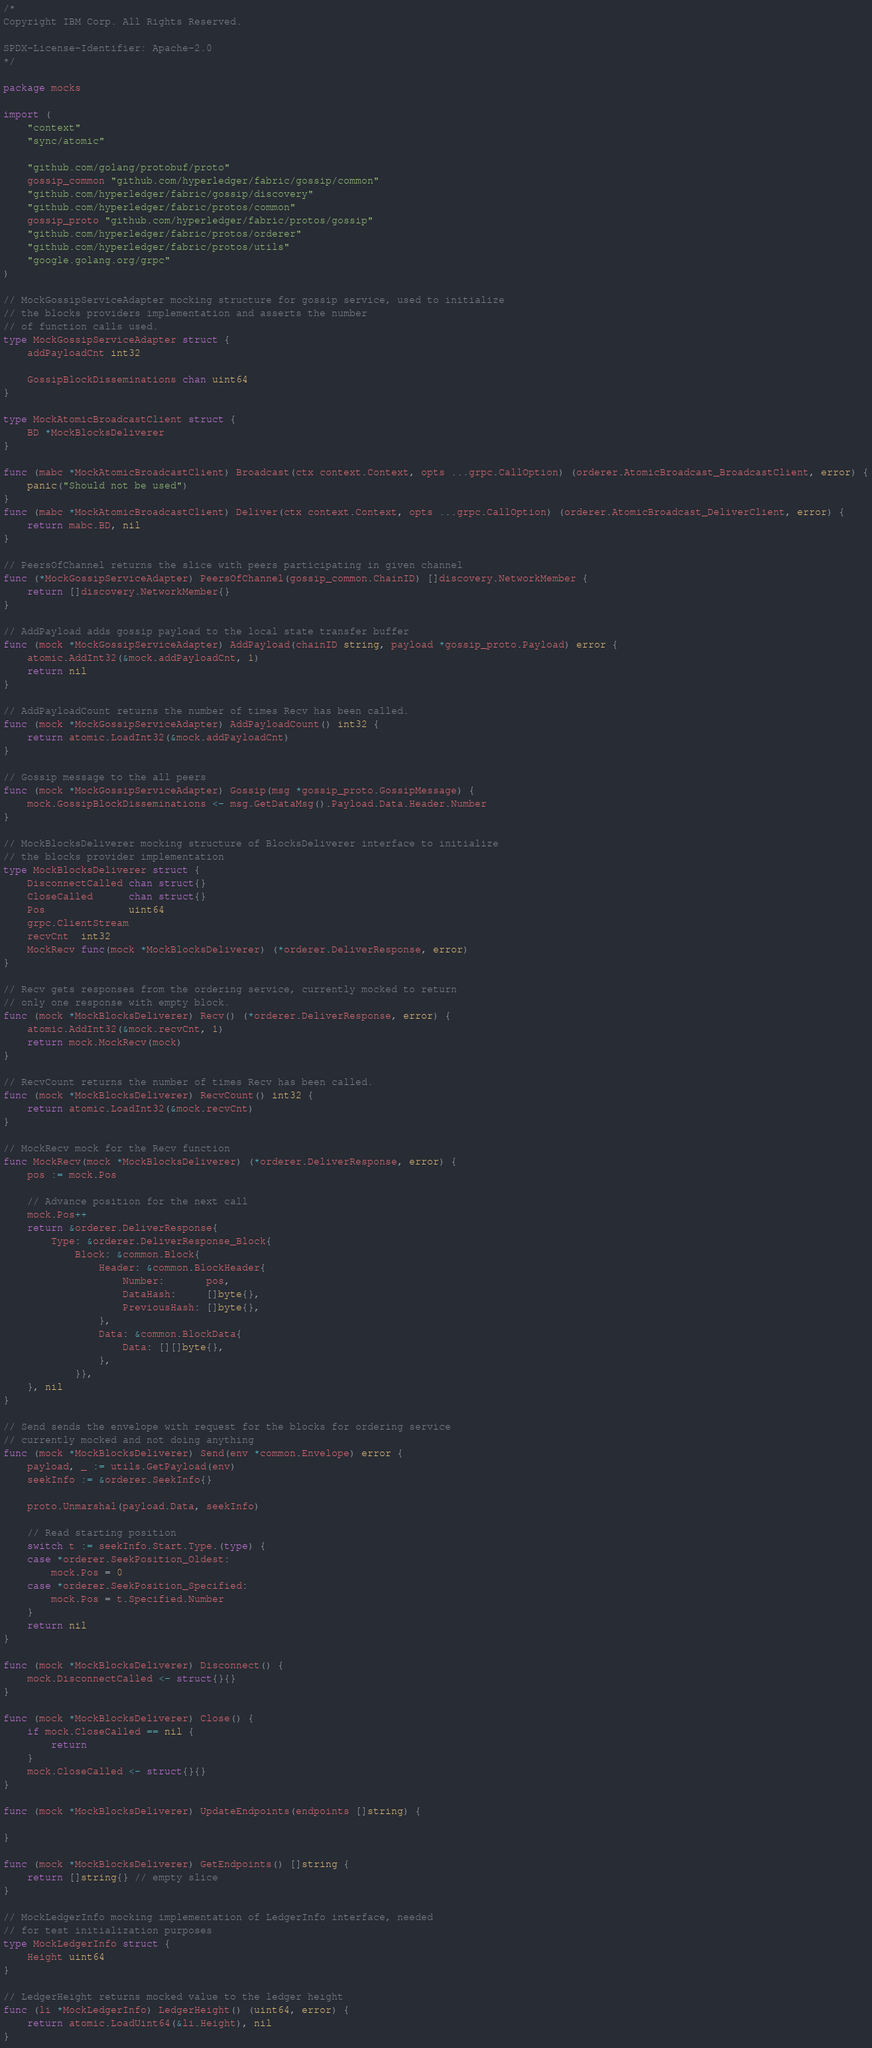Convert code to text. <code><loc_0><loc_0><loc_500><loc_500><_Go_>/*
Copyright IBM Corp. All Rights Reserved.

SPDX-License-Identifier: Apache-2.0
*/

package mocks

import (
	"context"
	"sync/atomic"

	"github.com/golang/protobuf/proto"
	gossip_common "github.com/hyperledger/fabric/gossip/common"
	"github.com/hyperledger/fabric/gossip/discovery"
	"github.com/hyperledger/fabric/protos/common"
	gossip_proto "github.com/hyperledger/fabric/protos/gossip"
	"github.com/hyperledger/fabric/protos/orderer"
	"github.com/hyperledger/fabric/protos/utils"
	"google.golang.org/grpc"
)

// MockGossipServiceAdapter mocking structure for gossip service, used to initialize
// the blocks providers implementation and asserts the number
// of function calls used.
type MockGossipServiceAdapter struct {
	addPayloadCnt int32

	GossipBlockDisseminations chan uint64
}

type MockAtomicBroadcastClient struct {
	BD *MockBlocksDeliverer
}

func (mabc *MockAtomicBroadcastClient) Broadcast(ctx context.Context, opts ...grpc.CallOption) (orderer.AtomicBroadcast_BroadcastClient, error) {
	panic("Should not be used")
}
func (mabc *MockAtomicBroadcastClient) Deliver(ctx context.Context, opts ...grpc.CallOption) (orderer.AtomicBroadcast_DeliverClient, error) {
	return mabc.BD, nil
}

// PeersOfChannel returns the slice with peers participating in given channel
func (*MockGossipServiceAdapter) PeersOfChannel(gossip_common.ChainID) []discovery.NetworkMember {
	return []discovery.NetworkMember{}
}

// AddPayload adds gossip payload to the local state transfer buffer
func (mock *MockGossipServiceAdapter) AddPayload(chainID string, payload *gossip_proto.Payload) error {
	atomic.AddInt32(&mock.addPayloadCnt, 1)
	return nil
}

// AddPayloadCount returns the number of times Recv has been called.
func (mock *MockGossipServiceAdapter) AddPayloadCount() int32 {
	return atomic.LoadInt32(&mock.addPayloadCnt)
}

// Gossip message to the all peers
func (mock *MockGossipServiceAdapter) Gossip(msg *gossip_proto.GossipMessage) {
	mock.GossipBlockDisseminations <- msg.GetDataMsg().Payload.Data.Header.Number
}

// MockBlocksDeliverer mocking structure of BlocksDeliverer interface to initialize
// the blocks provider implementation
type MockBlocksDeliverer struct {
	DisconnectCalled chan struct{}
	CloseCalled      chan struct{}
	Pos              uint64
	grpc.ClientStream
	recvCnt  int32
	MockRecv func(mock *MockBlocksDeliverer) (*orderer.DeliverResponse, error)
}

// Recv gets responses from the ordering service, currently mocked to return
// only one response with empty block.
func (mock *MockBlocksDeliverer) Recv() (*orderer.DeliverResponse, error) {
	atomic.AddInt32(&mock.recvCnt, 1)
	return mock.MockRecv(mock)
}

// RecvCount returns the number of times Recv has been called.
func (mock *MockBlocksDeliverer) RecvCount() int32 {
	return atomic.LoadInt32(&mock.recvCnt)
}

// MockRecv mock for the Recv function
func MockRecv(mock *MockBlocksDeliverer) (*orderer.DeliverResponse, error) {
	pos := mock.Pos

	// Advance position for the next call
	mock.Pos++
	return &orderer.DeliverResponse{
		Type: &orderer.DeliverResponse_Block{
			Block: &common.Block{
				Header: &common.BlockHeader{
					Number:       pos,
					DataHash:     []byte{},
					PreviousHash: []byte{},
				},
				Data: &common.BlockData{
					Data: [][]byte{},
				},
			}},
	}, nil
}

// Send sends the envelope with request for the blocks for ordering service
// currently mocked and not doing anything
func (mock *MockBlocksDeliverer) Send(env *common.Envelope) error {
	payload, _ := utils.GetPayload(env)
	seekInfo := &orderer.SeekInfo{}

	proto.Unmarshal(payload.Data, seekInfo)

	// Read starting position
	switch t := seekInfo.Start.Type.(type) {
	case *orderer.SeekPosition_Oldest:
		mock.Pos = 0
	case *orderer.SeekPosition_Specified:
		mock.Pos = t.Specified.Number
	}
	return nil
}

func (mock *MockBlocksDeliverer) Disconnect() {
	mock.DisconnectCalled <- struct{}{}
}

func (mock *MockBlocksDeliverer) Close() {
	if mock.CloseCalled == nil {
		return
	}
	mock.CloseCalled <- struct{}{}
}

func (mock *MockBlocksDeliverer) UpdateEndpoints(endpoints []string) {

}

func (mock *MockBlocksDeliverer) GetEndpoints() []string {
	return []string{} // empty slice
}

// MockLedgerInfo mocking implementation of LedgerInfo interface, needed
// for test initialization purposes
type MockLedgerInfo struct {
	Height uint64
}

// LedgerHeight returns mocked value to the ledger height
func (li *MockLedgerInfo) LedgerHeight() (uint64, error) {
	return atomic.LoadUint64(&li.Height), nil
}
</code> 